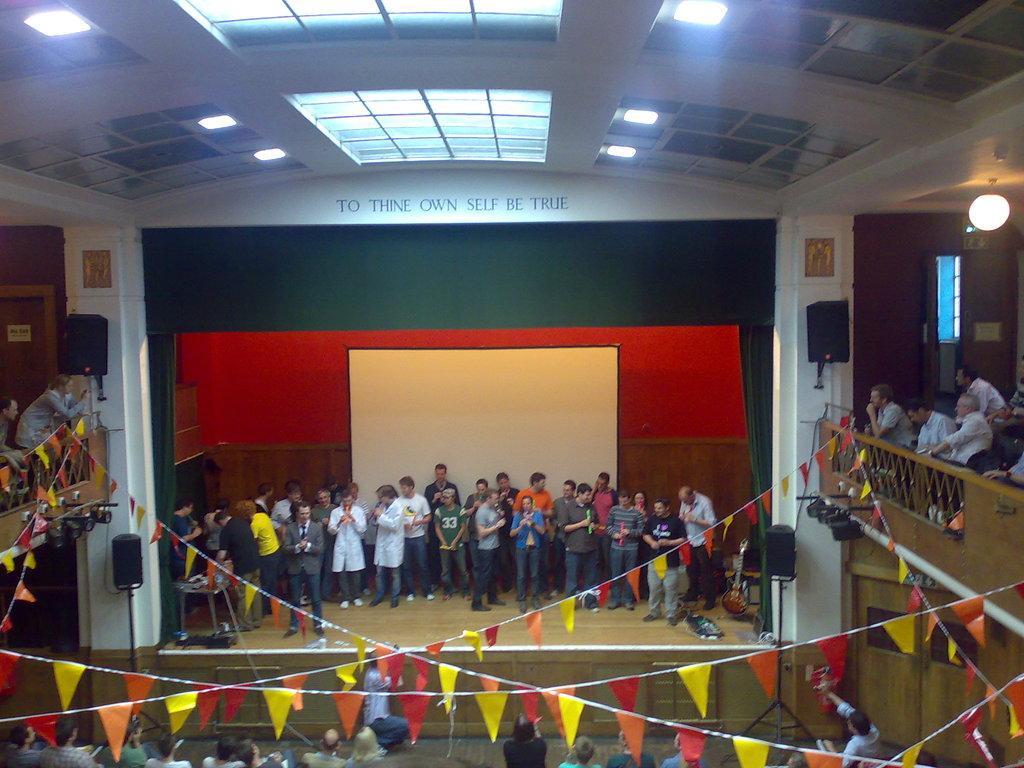Can you describe this image briefly? In this image, we can see people some are holding objects. In the background, there is a screen and we can see lights, boards on the wall and there are flags and some other objects. At the top, there is a roof. 